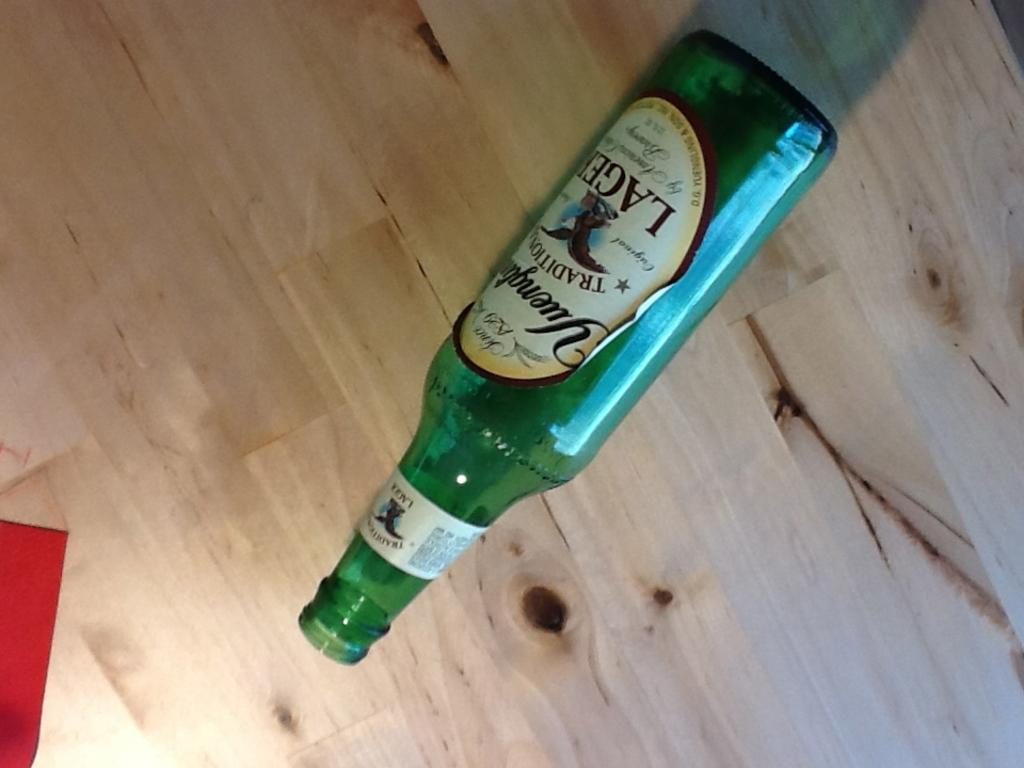Provide a one-sentence caption for the provided image. An empty bottle of Yuengling lager lays on its side. 